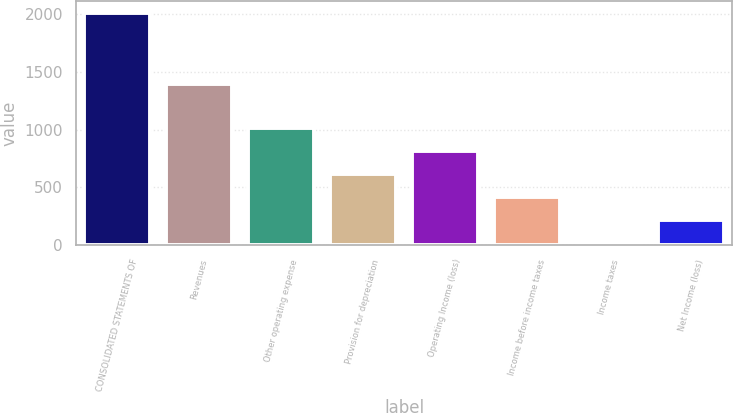Convert chart. <chart><loc_0><loc_0><loc_500><loc_500><bar_chart><fcel>CONSOLIDATED STATEMENTS OF<fcel>Revenues<fcel>Other operating expense<fcel>Provision for depreciation<fcel>Operating Income (loss)<fcel>Income before income taxes<fcel>Income taxes<fcel>Net Income (loss)<nl><fcel>2011<fcel>1391<fcel>1015.5<fcel>617.3<fcel>816.4<fcel>418.2<fcel>20<fcel>219.1<nl></chart> 